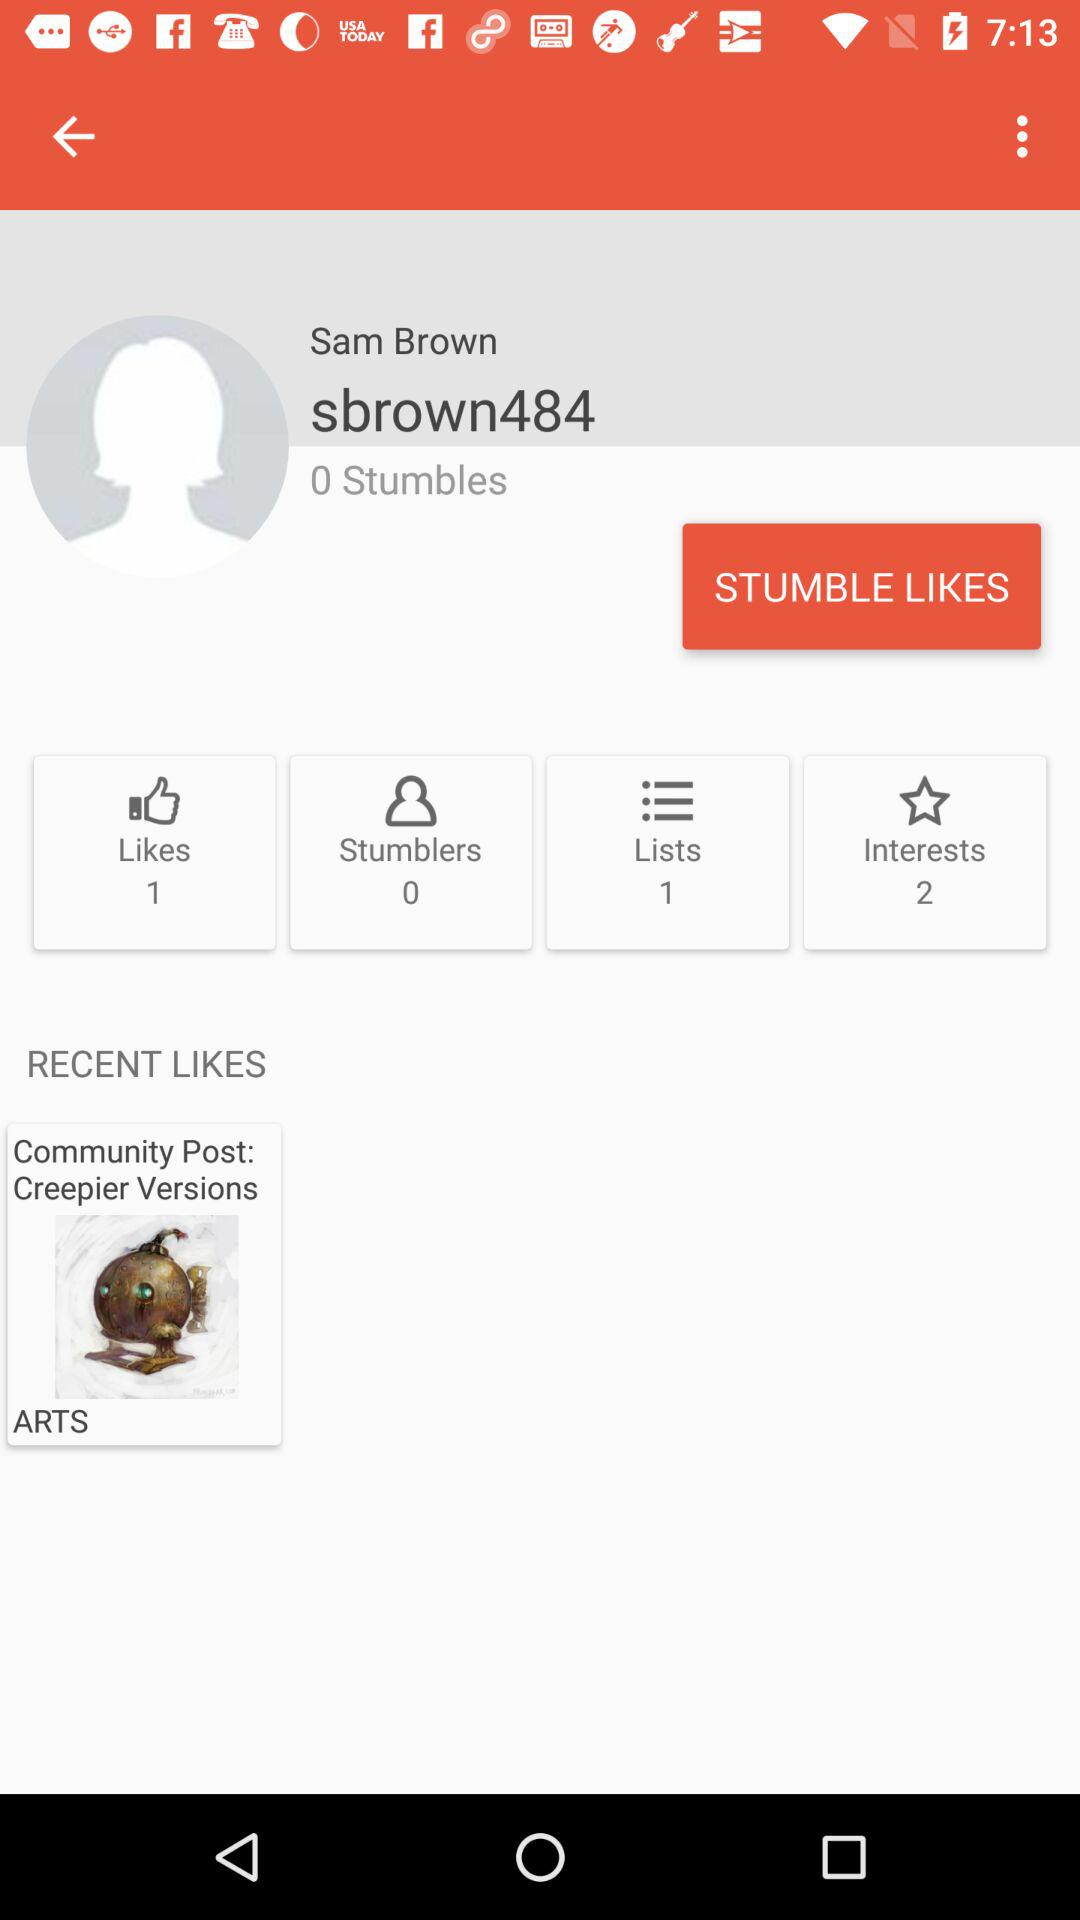What is the number of likes? The number of likes is 1. 